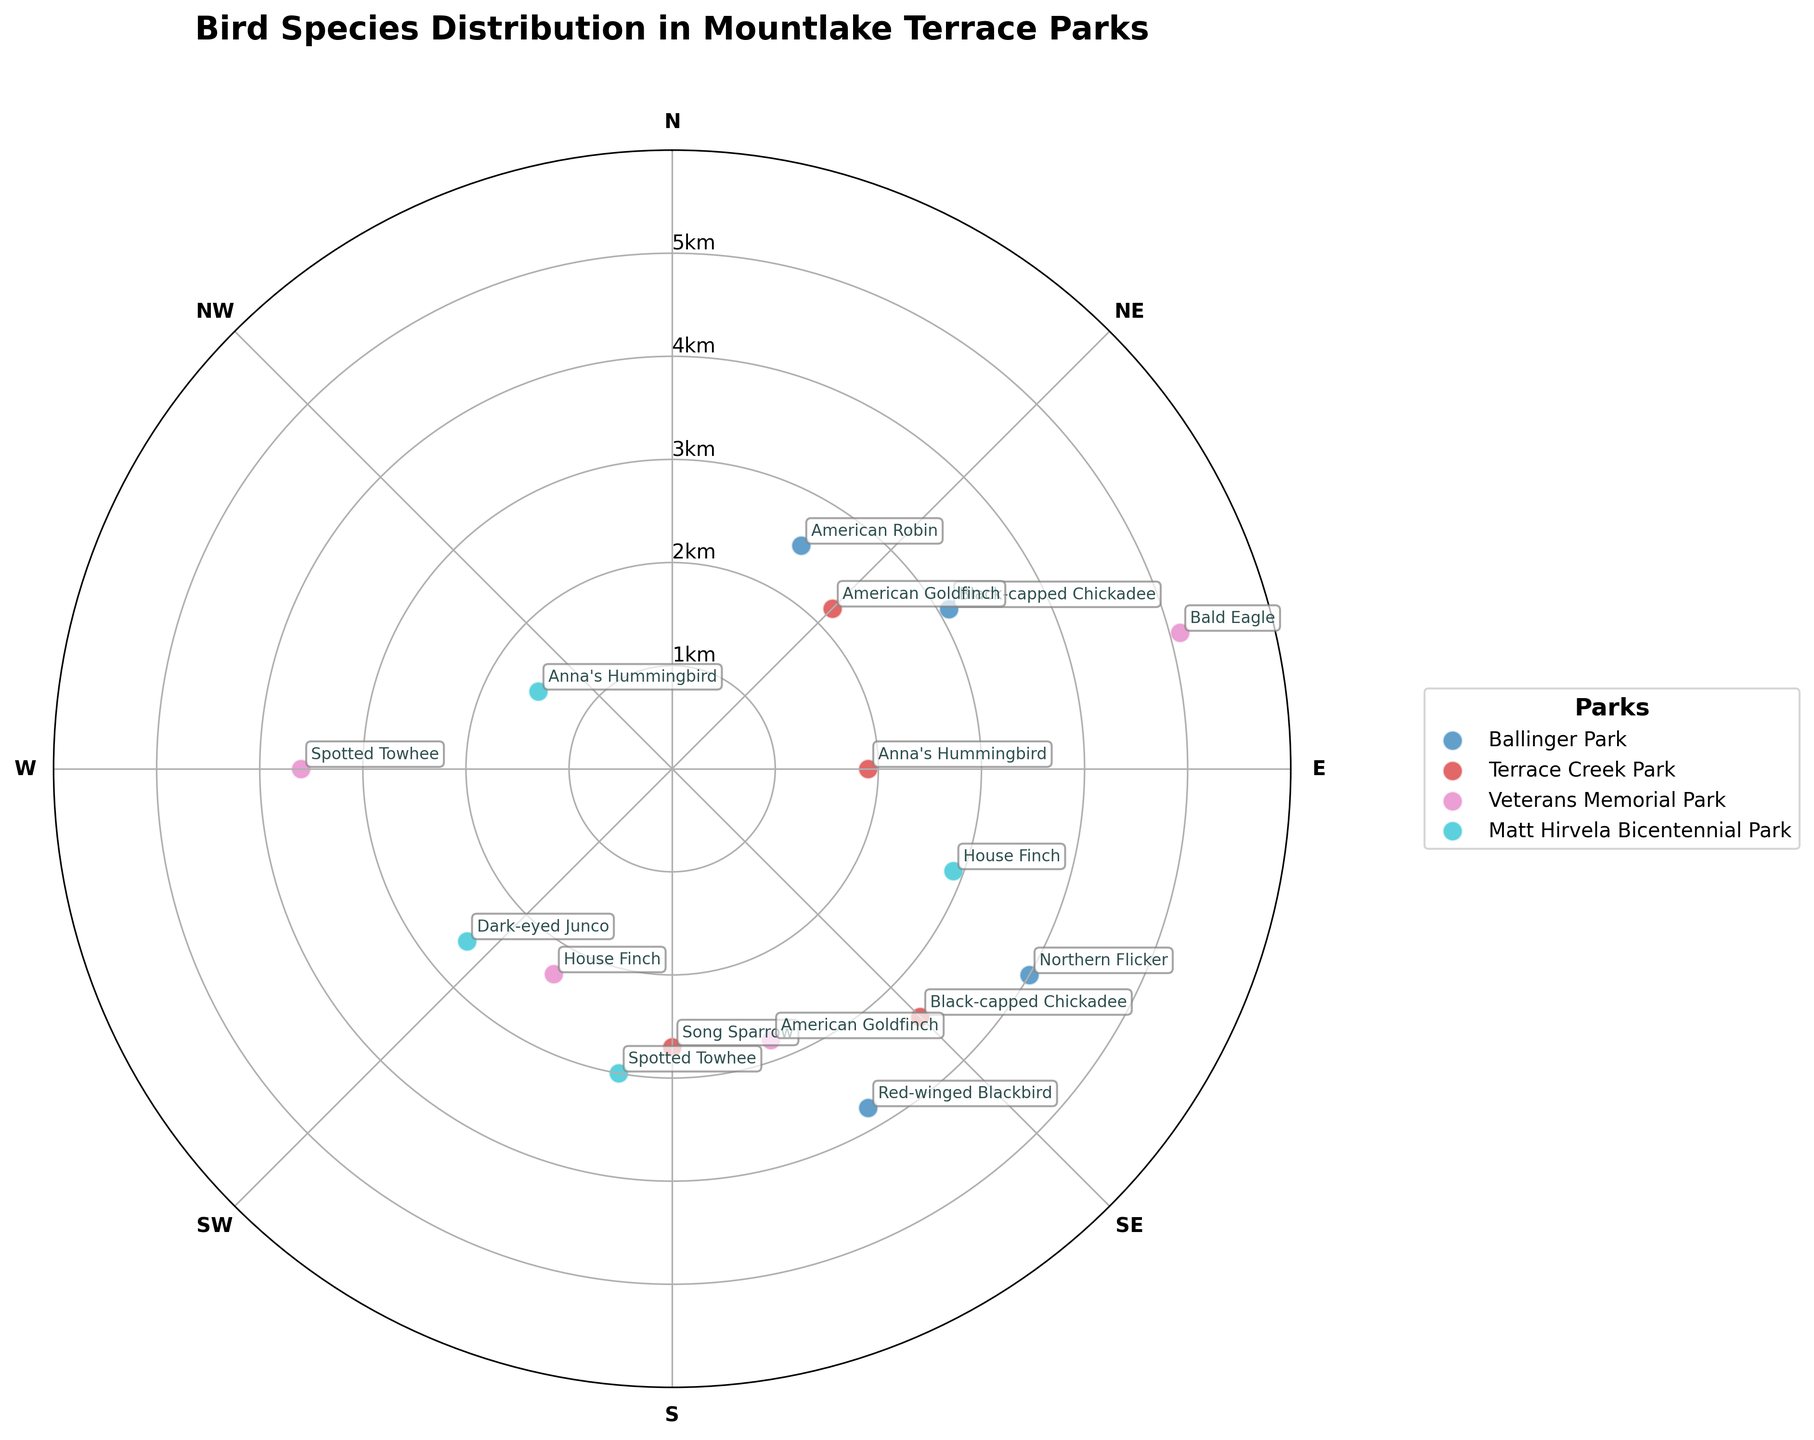What is the title of the chart? The title is usually located at the top of the chart. In this case, the title is bold and clearly says "Bird Species Distribution in Mountlake Terrace Parks".
Answer: Bird Species Distribution in Mountlake Terrace Parks Which park is associated with the color assigned to Veterans Memorial Park? By looking at the legend of the chart, you can match the color used in the data points to the corresponding park name. Veterans Memorial Park is associated with a particular color that can be identified in the legend.
Answer: Veterans Memorial Park What is the maximum distance a bird species was observed at Ballinger Park? To find this, you look for the data points labeled as "Ballinger Park" and check their distances. The highest value among them indicates the maximum distance. In this case, the Northern Flicker at Ballinger Park is observed at a distance of 4.0 km.
Answer: 4.0 km How many bird species were observed in Terrace Creek Park? By counting the data points labeled as "Terrace Creek Park", you can determine that four bird species were observed in this park.
Answer: 4 Which park has the bird species observed at the greatest distance, and what species is it? You need to identify the data point with the greatest distance, and then check the corresponding park and species labels. The Bald Eagle in Veterans Memorial Park is observed at the greatest distance of 5.1 km.
Answer: Veterans Memorial Park, Bald Eagle Which species is observed at the northernmost angle in Matt Hirvela Bicentennial Park? The northernmost angle is 0 degrees (North). Checking the data points for Matt Hirvela Bicentennial Park, you will find that Anna's Hummingbird is observed closest to the northernmost angle at 300 degrees (which is closest to North in this chart set-up).
Answer: Anna's Hummingbird What is the average distance of bird species observed in Veterans Memorial Park? To calculate the average distance, sum up the distances of all bird species observed in Veterans Memorial Park and then divide by the number of species: (5.1 + 2.8 + 2.3 + 3.6) / 4 = 13.8 / 4 = 3.45 km.
Answer: 3.45 km How does the observation distance of the Black-capped Chickadee differ between Ballinger Park and Terrace Creek Park? The Black-capped Chickadee is observed at 3.1 km in Ballinger Park and at 3.4 km in Terrace Creek Park, so the difference in observation distances is 3.4 km - 3.1 km = 0.3 km.
Answer: 0.3 km Which park has the most bird species observed at an angle between 45 and 135 degrees? Checking the given angles for each park's data points within this range, we count each bird species that appears within these angles: Ballinger Park has 2 species (60 and 120), Terrace Creek Park has 2 (45 and 90), Veterans Memorial Park has 1 (75), and Matt Hirvela Bicentennial Park has 1 (110). Tied for having the most species within that range are Ballinger Park and Terrace Creek Park, each with 2 species.
Answer: Ballinger Park and Terrace Creek Park 